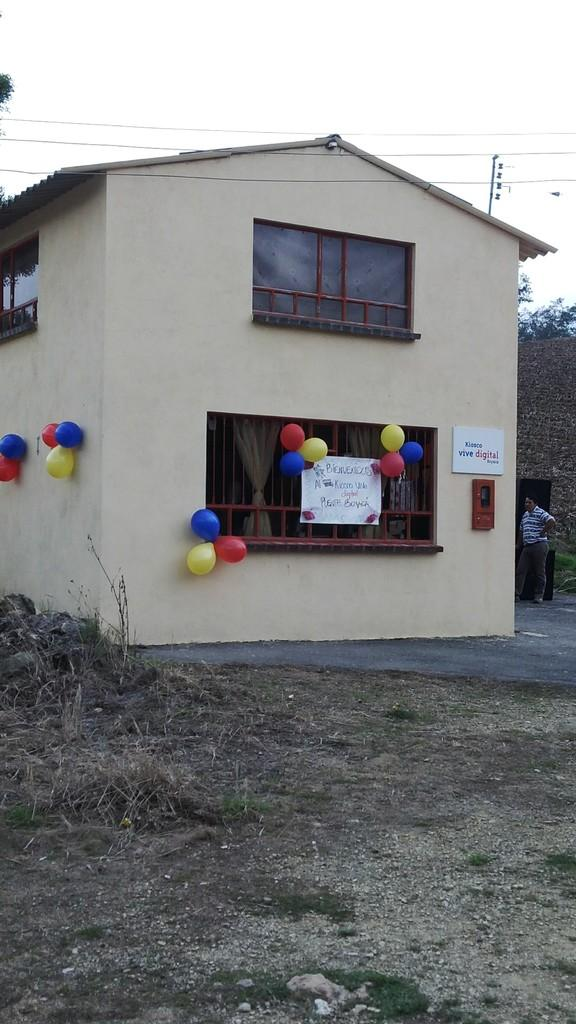What type of structure is visible in the image? There is a house in the image. What decorative items can be seen in the image? There are balloons and a poster visible in the image. What type of window treatment is present in the image? There are curtains in the image. How many windows are visible in the image? There are windows in the image. What other object can be seen in the image? There is a board in the image. Is there a person present in the image? Yes, there is a person in the image. What can be seen in the background of the image? The sky is visible in the background of the image. Can you tell me how many basketballs are on the line in the image? There are no basketballs or lines present in the image. 